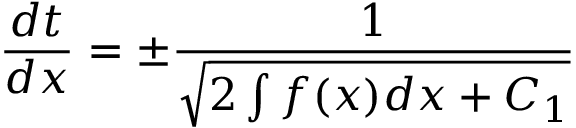<formula> <loc_0><loc_0><loc_500><loc_500>{ \frac { d t } { d x } } = \pm { \frac { 1 } { \sqrt { 2 \int f ( x ) d x + C _ { 1 } } } }</formula> 